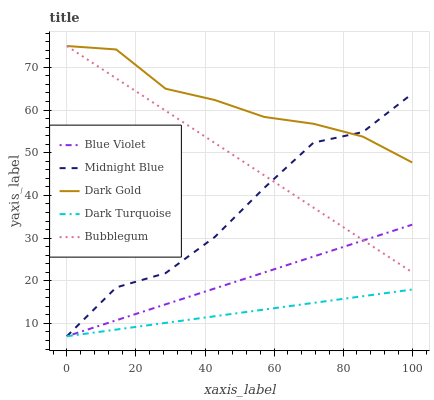Does Dark Turquoise have the minimum area under the curve?
Answer yes or no. Yes. Does Dark Gold have the maximum area under the curve?
Answer yes or no. Yes. Does Bubblegum have the minimum area under the curve?
Answer yes or no. No. Does Bubblegum have the maximum area under the curve?
Answer yes or no. No. Is Blue Violet the smoothest?
Answer yes or no. Yes. Is Midnight Blue the roughest?
Answer yes or no. Yes. Is Bubblegum the smoothest?
Answer yes or no. No. Is Bubblegum the roughest?
Answer yes or no. No. Does Dark Turquoise have the lowest value?
Answer yes or no. Yes. Does Bubblegum have the lowest value?
Answer yes or no. No. Does Dark Gold have the highest value?
Answer yes or no. Yes. Does Midnight Blue have the highest value?
Answer yes or no. No. Is Blue Violet less than Dark Gold?
Answer yes or no. Yes. Is Bubblegum greater than Dark Turquoise?
Answer yes or no. Yes. Does Midnight Blue intersect Dark Turquoise?
Answer yes or no. Yes. Is Midnight Blue less than Dark Turquoise?
Answer yes or no. No. Is Midnight Blue greater than Dark Turquoise?
Answer yes or no. No. Does Blue Violet intersect Dark Gold?
Answer yes or no. No. 